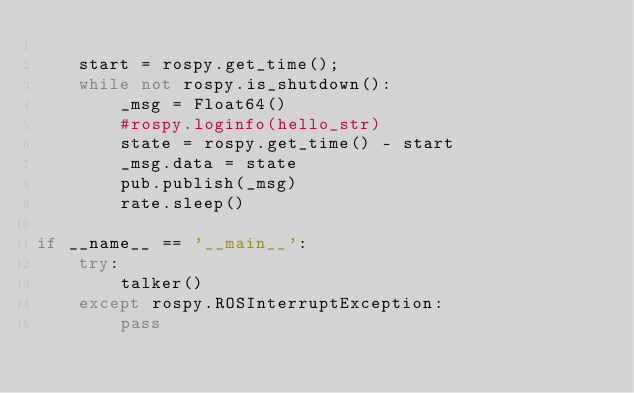Convert code to text. <code><loc_0><loc_0><loc_500><loc_500><_Python_>	
	start = rospy.get_time();
	while not rospy.is_shutdown():
		_msg = Float64()
		#rospy.loginfo(hello_str)
		state = rospy.get_time() - start
		_msg.data = state
		pub.publish(_msg)
		rate.sleep()
 
if __name__ == '__main__':
	try:
		talker()
	except rospy.ROSInterruptException:
		pass


</code> 